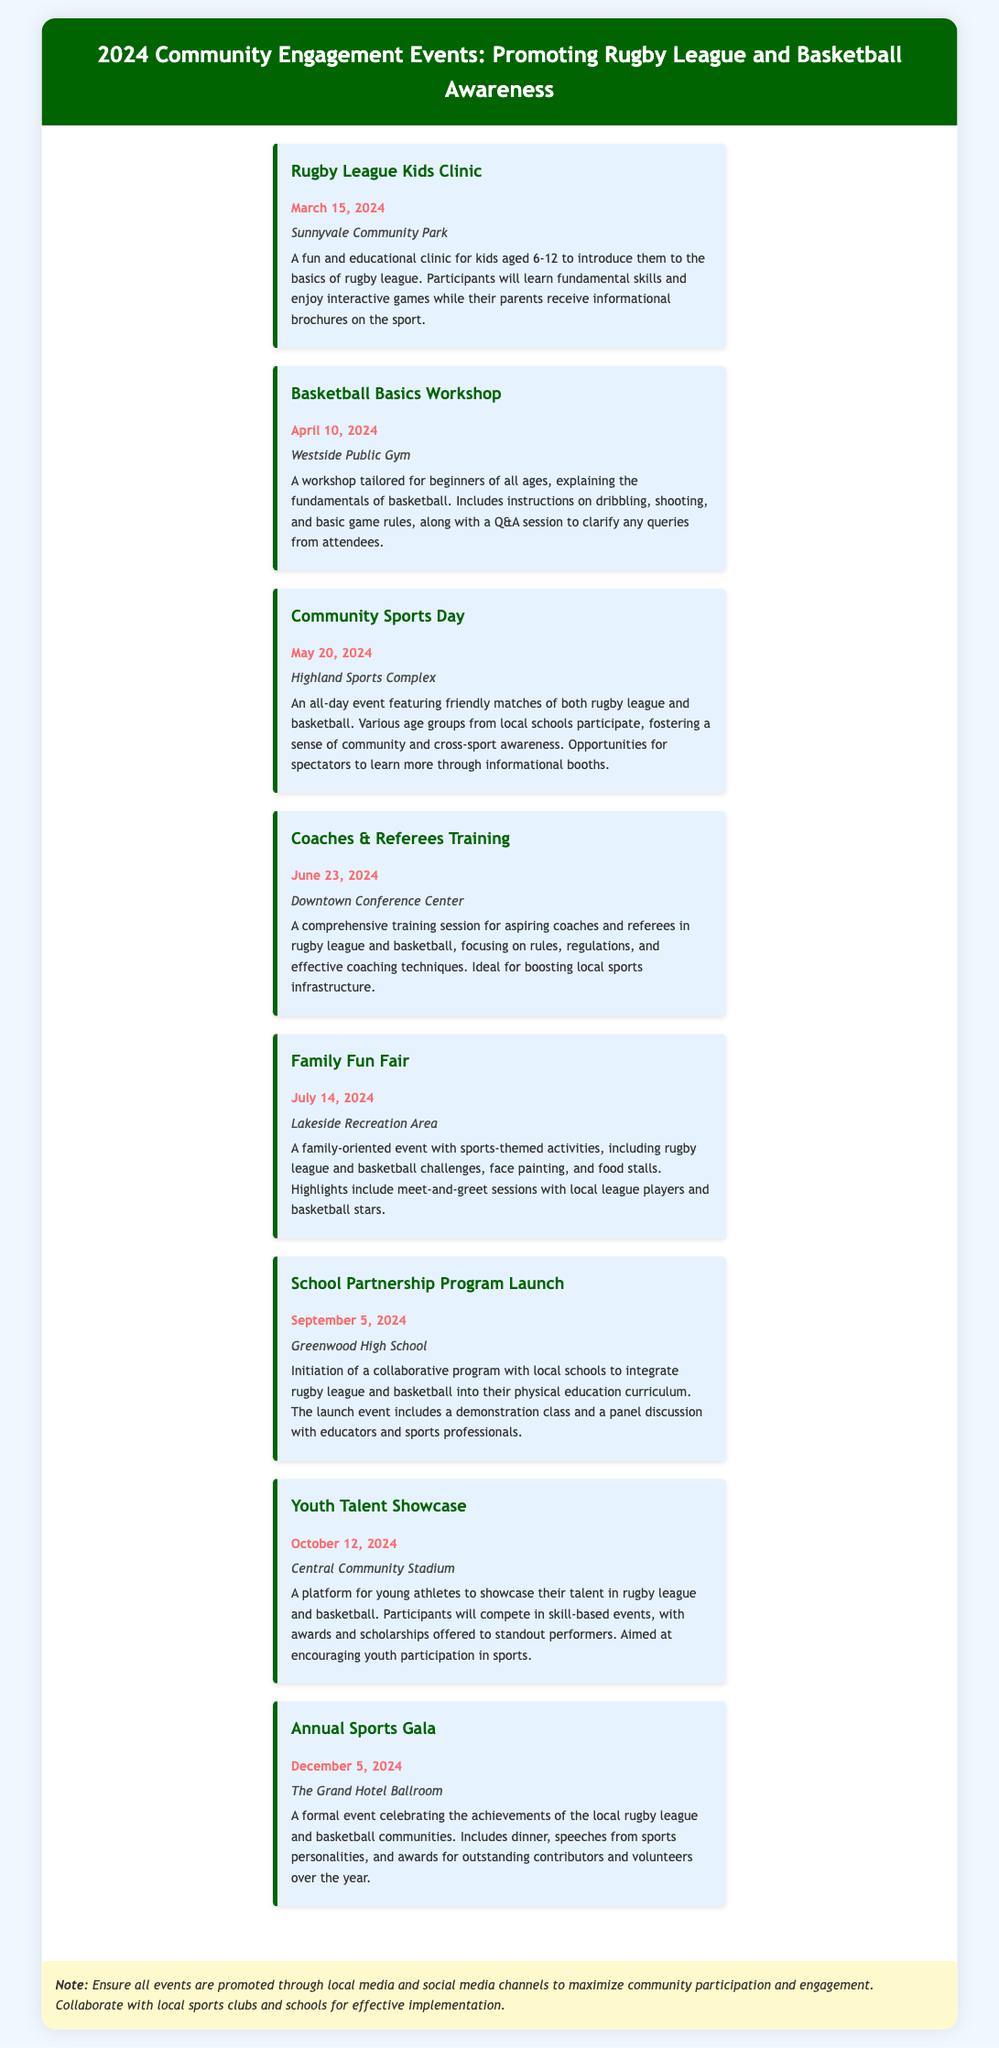What is the date of the Rugby League Kids Clinic? The date for the Rugby League Kids Clinic is specified in the document.
Answer: March 15, 2024 Where is the Basketball Basics Workshop held? The location for the Basketball Basics Workshop is mentioned in the document.
Answer: Westside Public Gym What is the main focus of the Community Sports Day? The document describes the Community Sports Day as featuring matches of both sports, indicating its dual focus.
Answer: Rugby league and basketball When will the Youth Talent Showcase take place? The specific date for the Youth Talent Showcase is listed in the document.
Answer: October 12, 2024 What type of event is the Annual Sports Gala? The document classifies the Annual Sports Gala as a formal gathering celebrating achievements.
Answer: Formal event Which event aims to incorporate rugby league and basketball into school curricula? The event dedicated to partnering with local schools on this initiative is highlighted in the document.
Answer: School Partnership Program Launch How many events are scheduled in the document? By counting the events listed, we determine the total number of events present.
Answer: Eight 